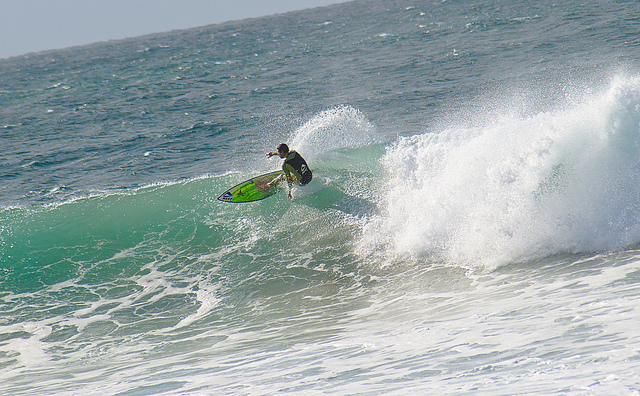Describe the surfing conditions in the image. The conditions appear ideal for surfing with clean waves, good wave height, and no visible chop. It's likely the wind conditions are favorable as well. What time of day does this seem to be? Based on the lighting and shadows, it seems to be midday, when the sun is high and luminosity on the water is bright. 